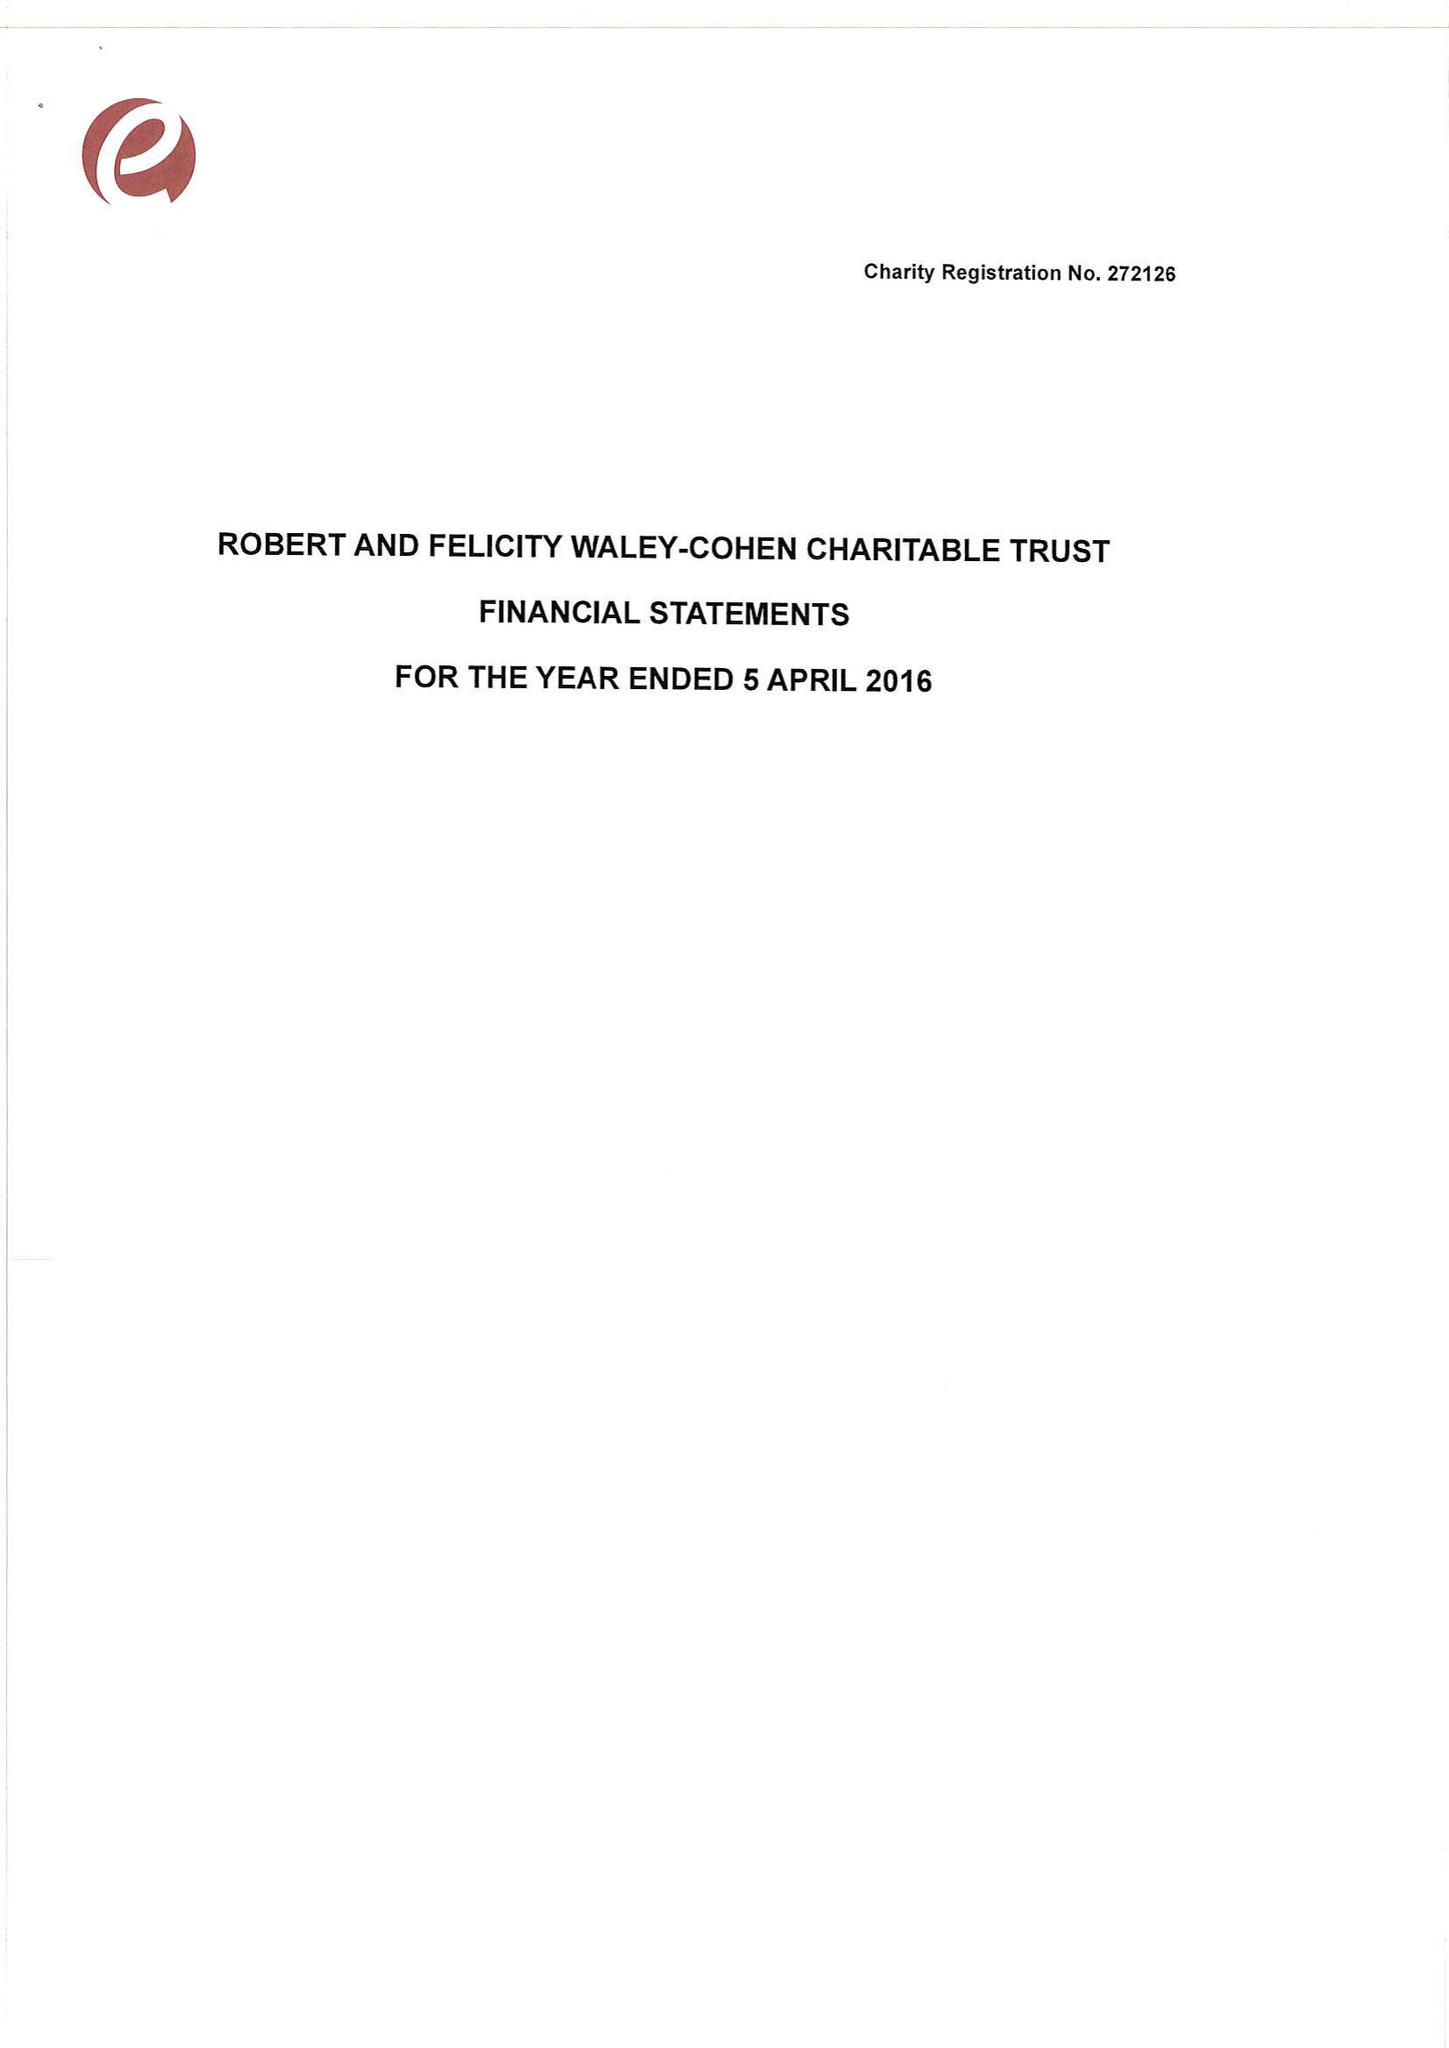What is the value for the charity_number?
Answer the question using a single word or phrase. 272126 